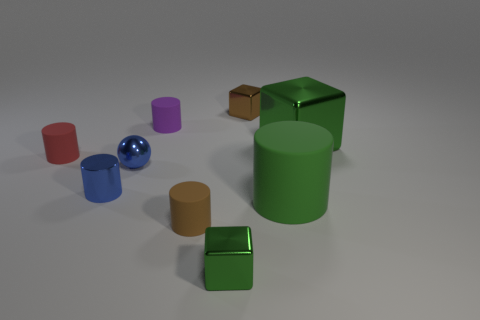There is a shiny object that is on the right side of the big green object that is in front of the green cube behind the small blue sphere; how big is it?
Offer a terse response. Large. How many rubber objects are either small cylinders or purple objects?
Ensure brevity in your answer.  3. Is the shape of the purple rubber object the same as the matte thing on the left side of the shiny cylinder?
Provide a short and direct response. Yes. Are there more objects that are behind the blue ball than purple matte things left of the metallic cylinder?
Give a very brief answer. Yes. Is there any other thing of the same color as the small ball?
Keep it short and to the point. Yes. Are there any brown cylinders that are in front of the metal object that is to the right of the tiny object behind the purple cylinder?
Offer a very short reply. Yes. There is a small metal thing behind the large green block; does it have the same shape as the purple thing?
Offer a very short reply. No. Are there fewer green cylinders behind the tiny red rubber object than small blue metallic things on the left side of the brown matte object?
Provide a short and direct response. Yes. What is the small blue cylinder made of?
Provide a succinct answer. Metal. Does the small metal ball have the same color as the metallic cylinder that is behind the small green shiny cube?
Give a very brief answer. Yes. 